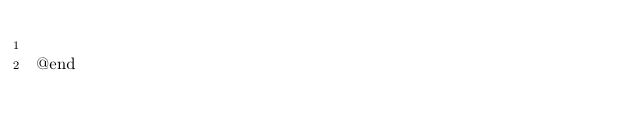Convert code to text. <code><loc_0><loc_0><loc_500><loc_500><_C_>
@end

</code> 